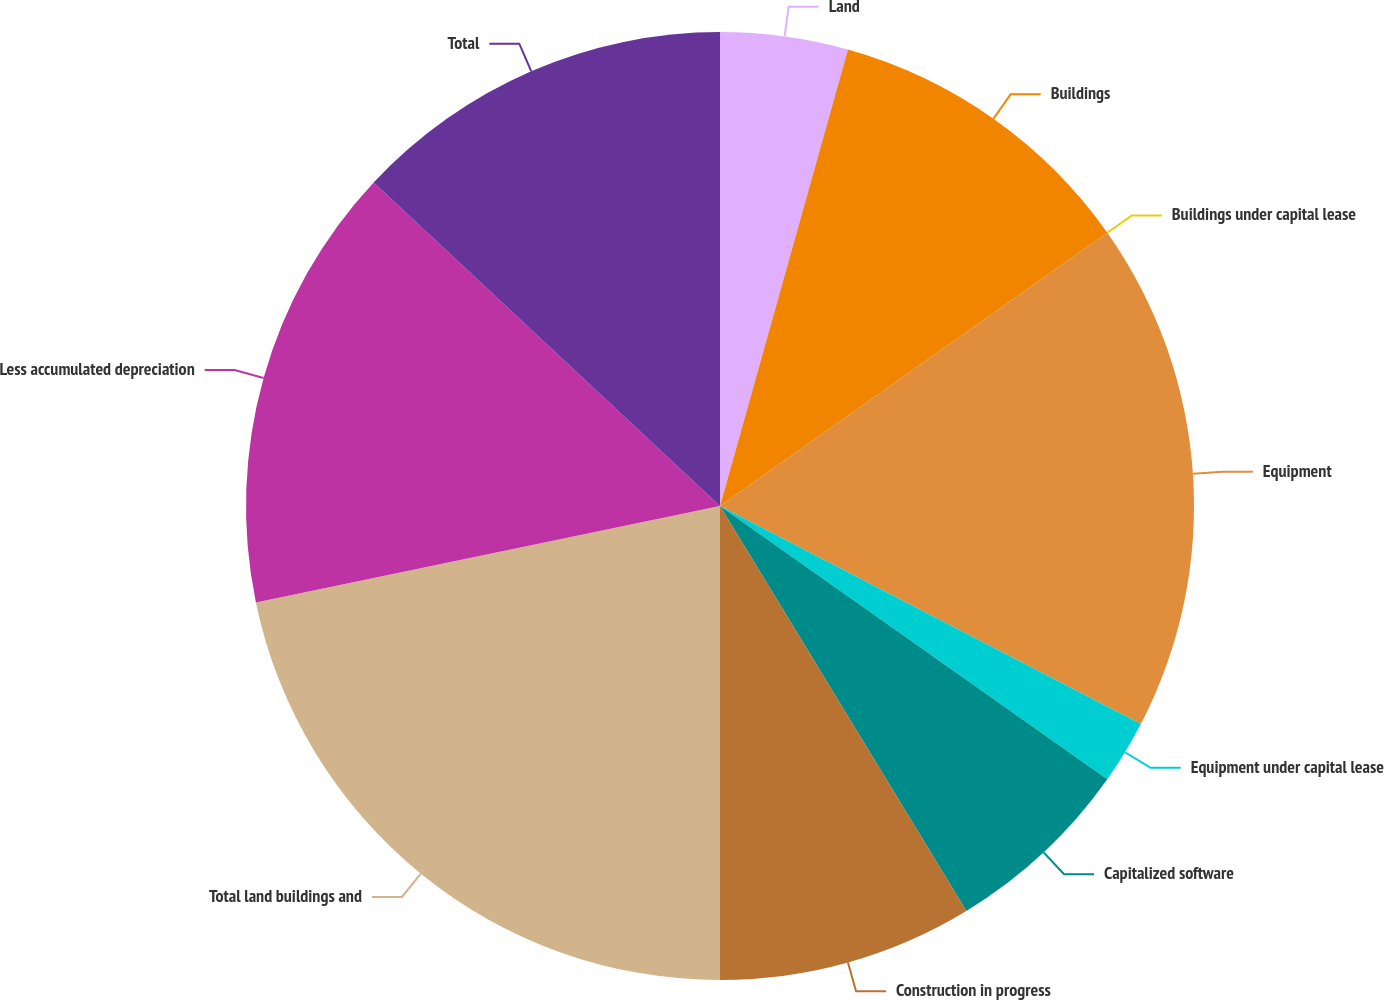<chart> <loc_0><loc_0><loc_500><loc_500><pie_chart><fcel>Land<fcel>Buildings<fcel>Buildings under capital lease<fcel>Equipment<fcel>Equipment under capital lease<fcel>Capitalized software<fcel>Construction in progress<fcel>Total land buildings and<fcel>Less accumulated depreciation<fcel>Total<nl><fcel>4.35%<fcel>10.87%<fcel>0.0%<fcel>17.39%<fcel>2.17%<fcel>6.52%<fcel>8.7%<fcel>21.74%<fcel>15.22%<fcel>13.04%<nl></chart> 